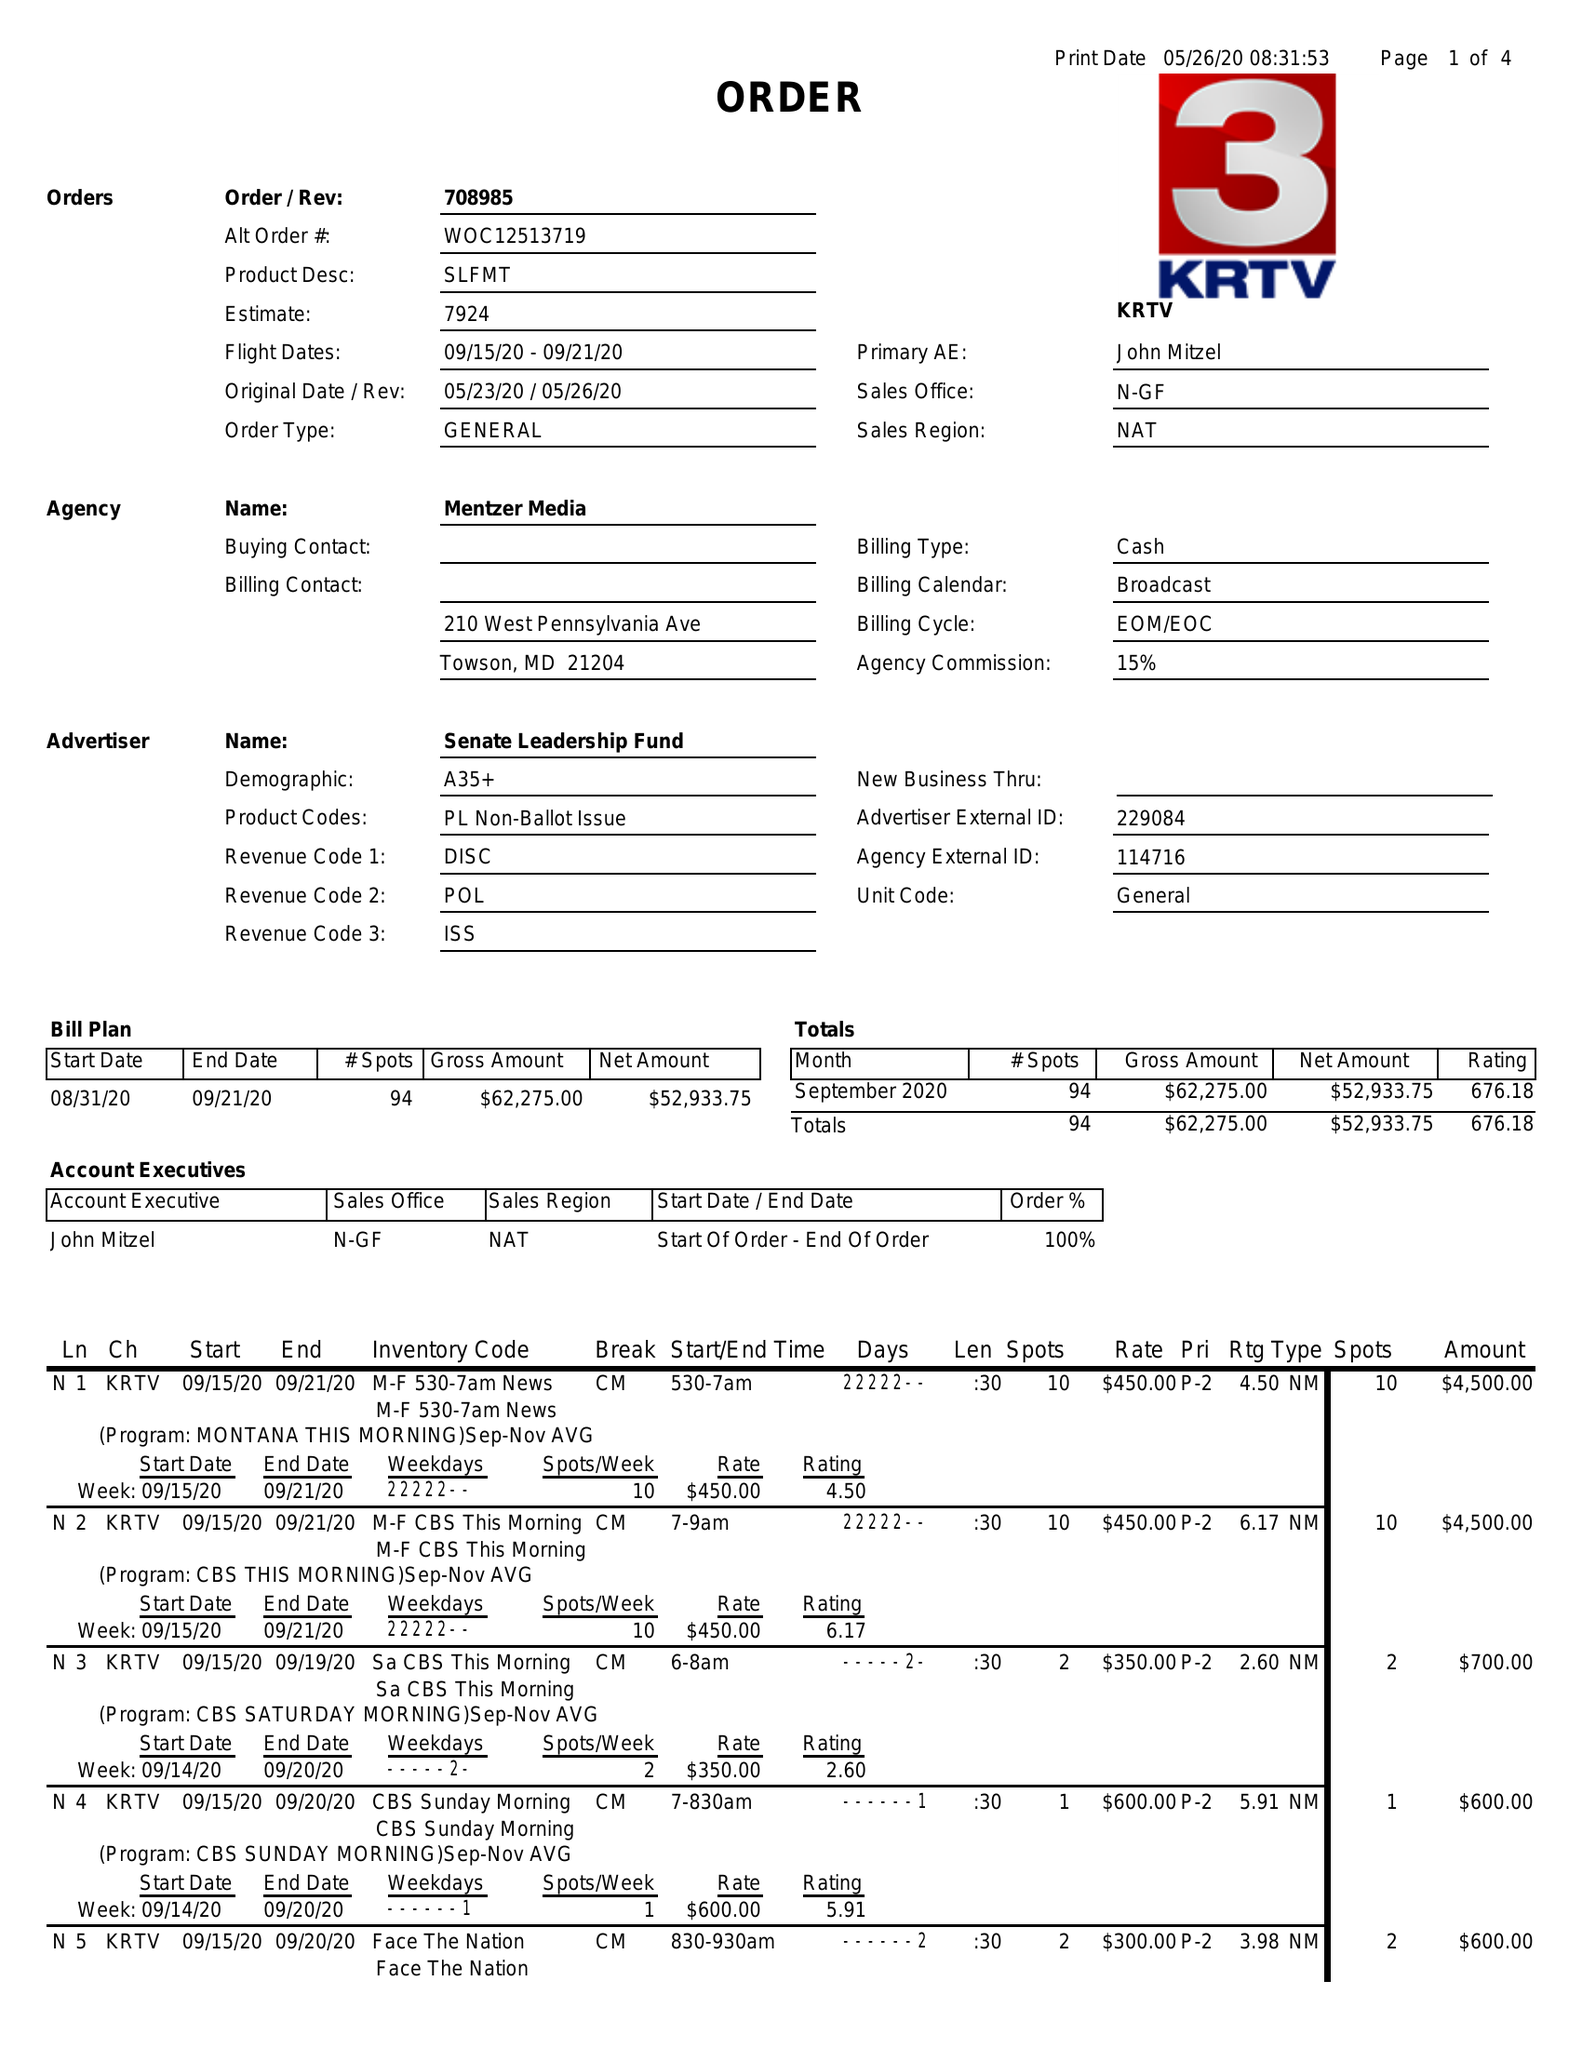What is the value for the gross_amount?
Answer the question using a single word or phrase. 62275.00 